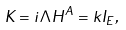<formula> <loc_0><loc_0><loc_500><loc_500>K = i \Lambda H ^ { A } = k I _ { E } ,</formula> 